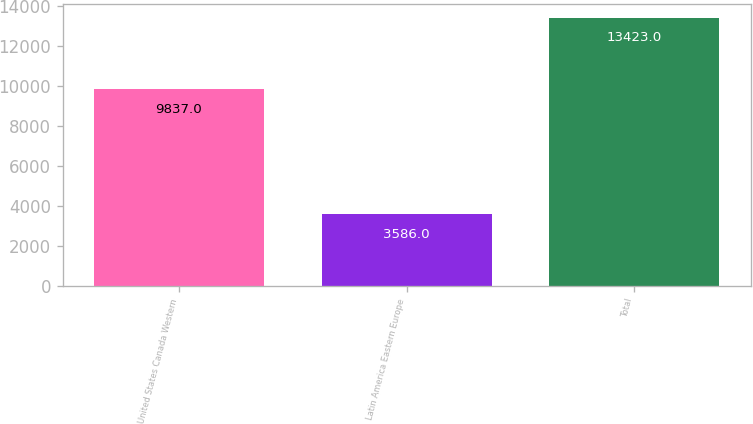<chart> <loc_0><loc_0><loc_500><loc_500><bar_chart><fcel>United States Canada Western<fcel>Latin America Eastern Europe<fcel>Total<nl><fcel>9837<fcel>3586<fcel>13423<nl></chart> 